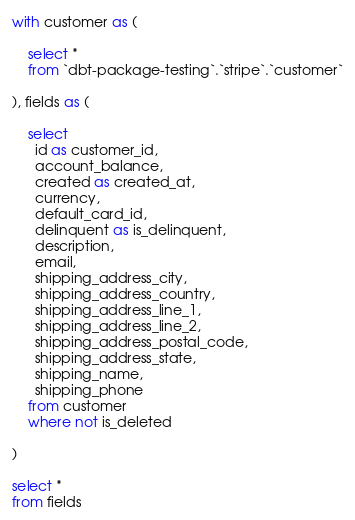Convert code to text. <code><loc_0><loc_0><loc_500><loc_500><_SQL_>with customer as (

    select *
    from `dbt-package-testing`.`stripe`.`customer`

), fields as (

    select 
      id as customer_id,
      account_balance,
      created as created_at,
      currency,
      default_card_id,
      delinquent as is_delinquent,
      description,
      email,
      shipping_address_city,
      shipping_address_country,
      shipping_address_line_1,
      shipping_address_line_2,
      shipping_address_postal_code,
      shipping_address_state,
      shipping_name,
      shipping_phone
    from customer
    where not is_deleted

)

select *
from fields</code> 